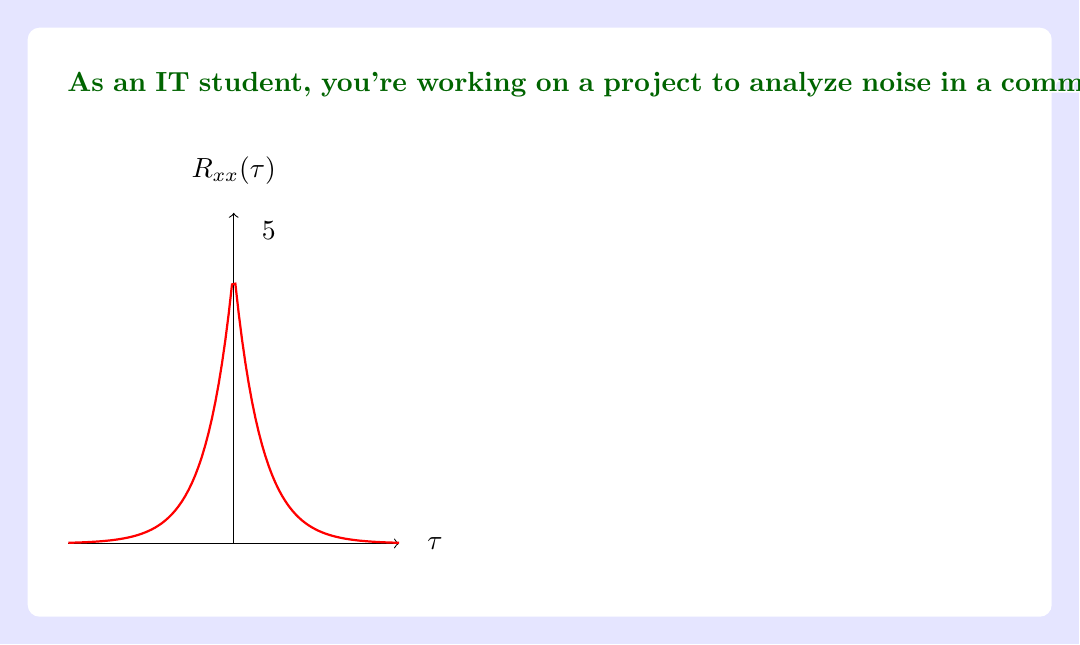Give your solution to this math problem. To find the power spectral density (PSD) of the noise signal, we need to take the Fourier transform of the autocorrelation function. Let's approach this step-by-step:

1) The given autocorrelation function is $R_{xx}(\tau) = 5e^{-2|\tau|}$.

2) The power spectral density $S_{xx}(f)$ is the Fourier transform of $R_{xx}(\tau)$:

   $$S_{xx}(f) = \int_{-\infty}^{\infty} R_{xx}(\tau) e^{-j2\pi f\tau} d\tau$$

3) Substituting our $R_{xx}(\tau)$:

   $$S_{xx}(f) = \int_{-\infty}^{\infty} 5e^{-2|\tau|} e^{-j2\pi f\tau} d\tau$$

4) This integral can be split into two parts due to the absolute value:

   $$S_{xx}(f) = 5\int_{0}^{\infty} e^{-2\tau} e^{-j2\pi f\tau} d\tau + 5\int_{-\infty}^{0} e^{2\tau} e^{-j2\pi f\tau} d\tau$$

5) Solving these integrals:

   $$S_{xx}(f) = 5\left[\frac{1}{2+j2\pi f} + \frac{1}{2-j2\pi f}\right]$$

6) Simplifying:

   $$S_{xx}(f) = 5\left[\frac{2}{4+(2\pi f)^2}\right] = \frac{10}{4+(2\pi f)^2}$$

This is the power spectral density of the noise signal.
Answer: $$S_{xx}(f) = \frac{10}{4+(2\pi f)^2}$$ 